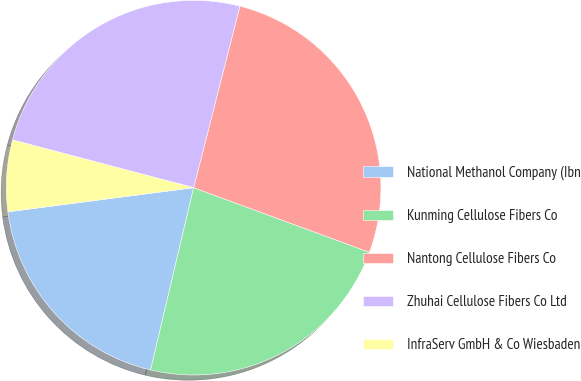Convert chart to OTSL. <chart><loc_0><loc_0><loc_500><loc_500><pie_chart><fcel>National Methanol Company (Ibn<fcel>Kunming Cellulose Fibers Co<fcel>Nantong Cellulose Fibers Co<fcel>Zhuhai Cellulose Fibers Co Ltd<fcel>InfraServ GmbH & Co Wiesbaden<nl><fcel>19.25%<fcel>23.09%<fcel>26.64%<fcel>24.87%<fcel>6.16%<nl></chart> 